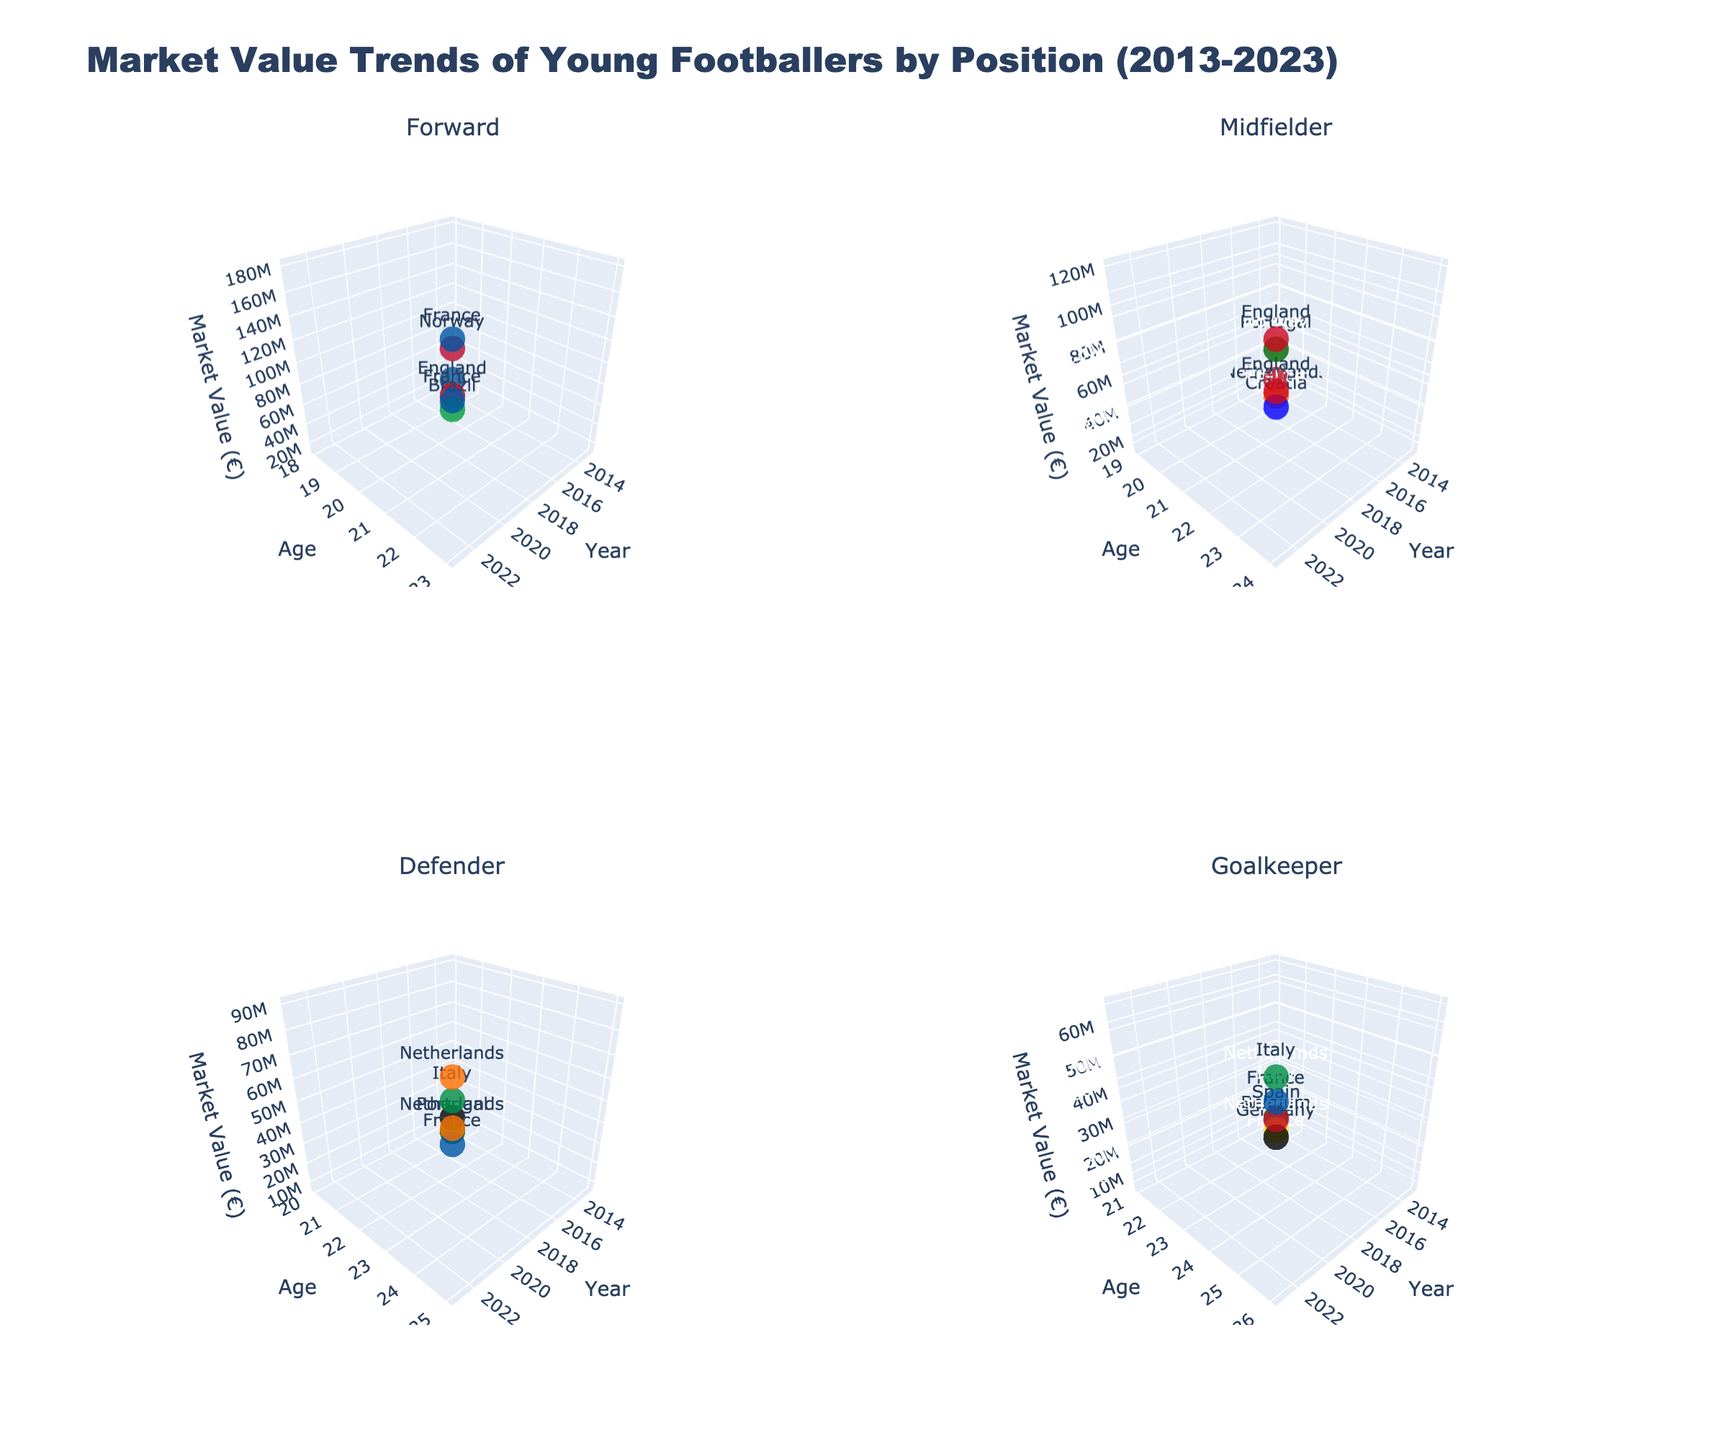What's the title of the figure? The title is located at the top of the figure, and it usually describes the overall content of the plot.
Answer: Market Value Trends of Young Footballers by Position (2013-2023) How many positions are represented in the figure? The figure has separate 3D subplots for each position. We can count the number of subplot titles to determine this.
Answer: Four Which nationality has the highest market value for a forward in 2023? Look at the subplot for forwards, identify the 2023 data points by checking the "Year" on the X-axis, and then find the highest "Market Value" on the Z-axis. The nationality is marked by color and text.
Answer: France What is the total market value of defenders in 2019? Identify the defender subplot, select the 2019 data point by checking the "Year" on the X-axis, and then extract the corresponding "Market Value" on the Z-axis. Sum up these values.
Answer: 45,000,000 euros Which position shows the most significant increase in market value from 2013 to 2023? Compare the market values for each position at 2013 and 2023 by looking at the Z-axis values in the subplots for the corresponding years and calculate the difference.
Answer: Forward What's the average age of midfielders in 2021? Look at the subplot for midfielders and identify the data point of the year 2021 by checking the X-axis. Note the ages from corresponding points on the Y-axis and calculate the average.
Answer: 23 Which nationality appears most frequently across all positions? Check the color mark and text annotations for all data points across all subplots to count the occurrences of each nationality.
Answer: France How do goalkeepers' market values in 2023 compare to those in 2013? Compare the market value data points for goalkeepers at year 2023 and 2013 by looking at the Z-axis in the goalkeeper subplot. Note the difference.
Answer: Much higher in 2023 Which midfielder had the highest market value in 2017, and what was the value? Look at the midfielder subplot, identify the 2017 data points by checking the X-axis, and then find the highest Z-axis value.
Answer: Croatia, 30,000,000 euros What trend do you notice in the age of forwards from 2013 to 2023? Analyze the age (Y-axis) in the forward subplot and track how it changes from 2013 to 2023.
Answer: Forward players' ages increase over the period 